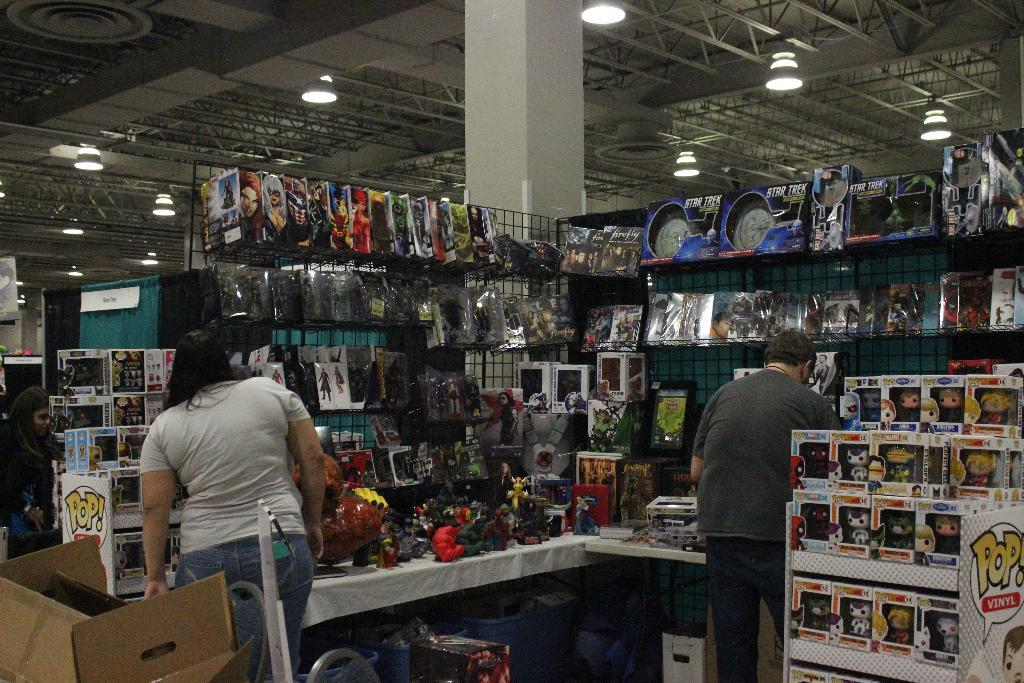<image>
Give a short and clear explanation of the subsequent image. people in a store with a sign near that says pop 